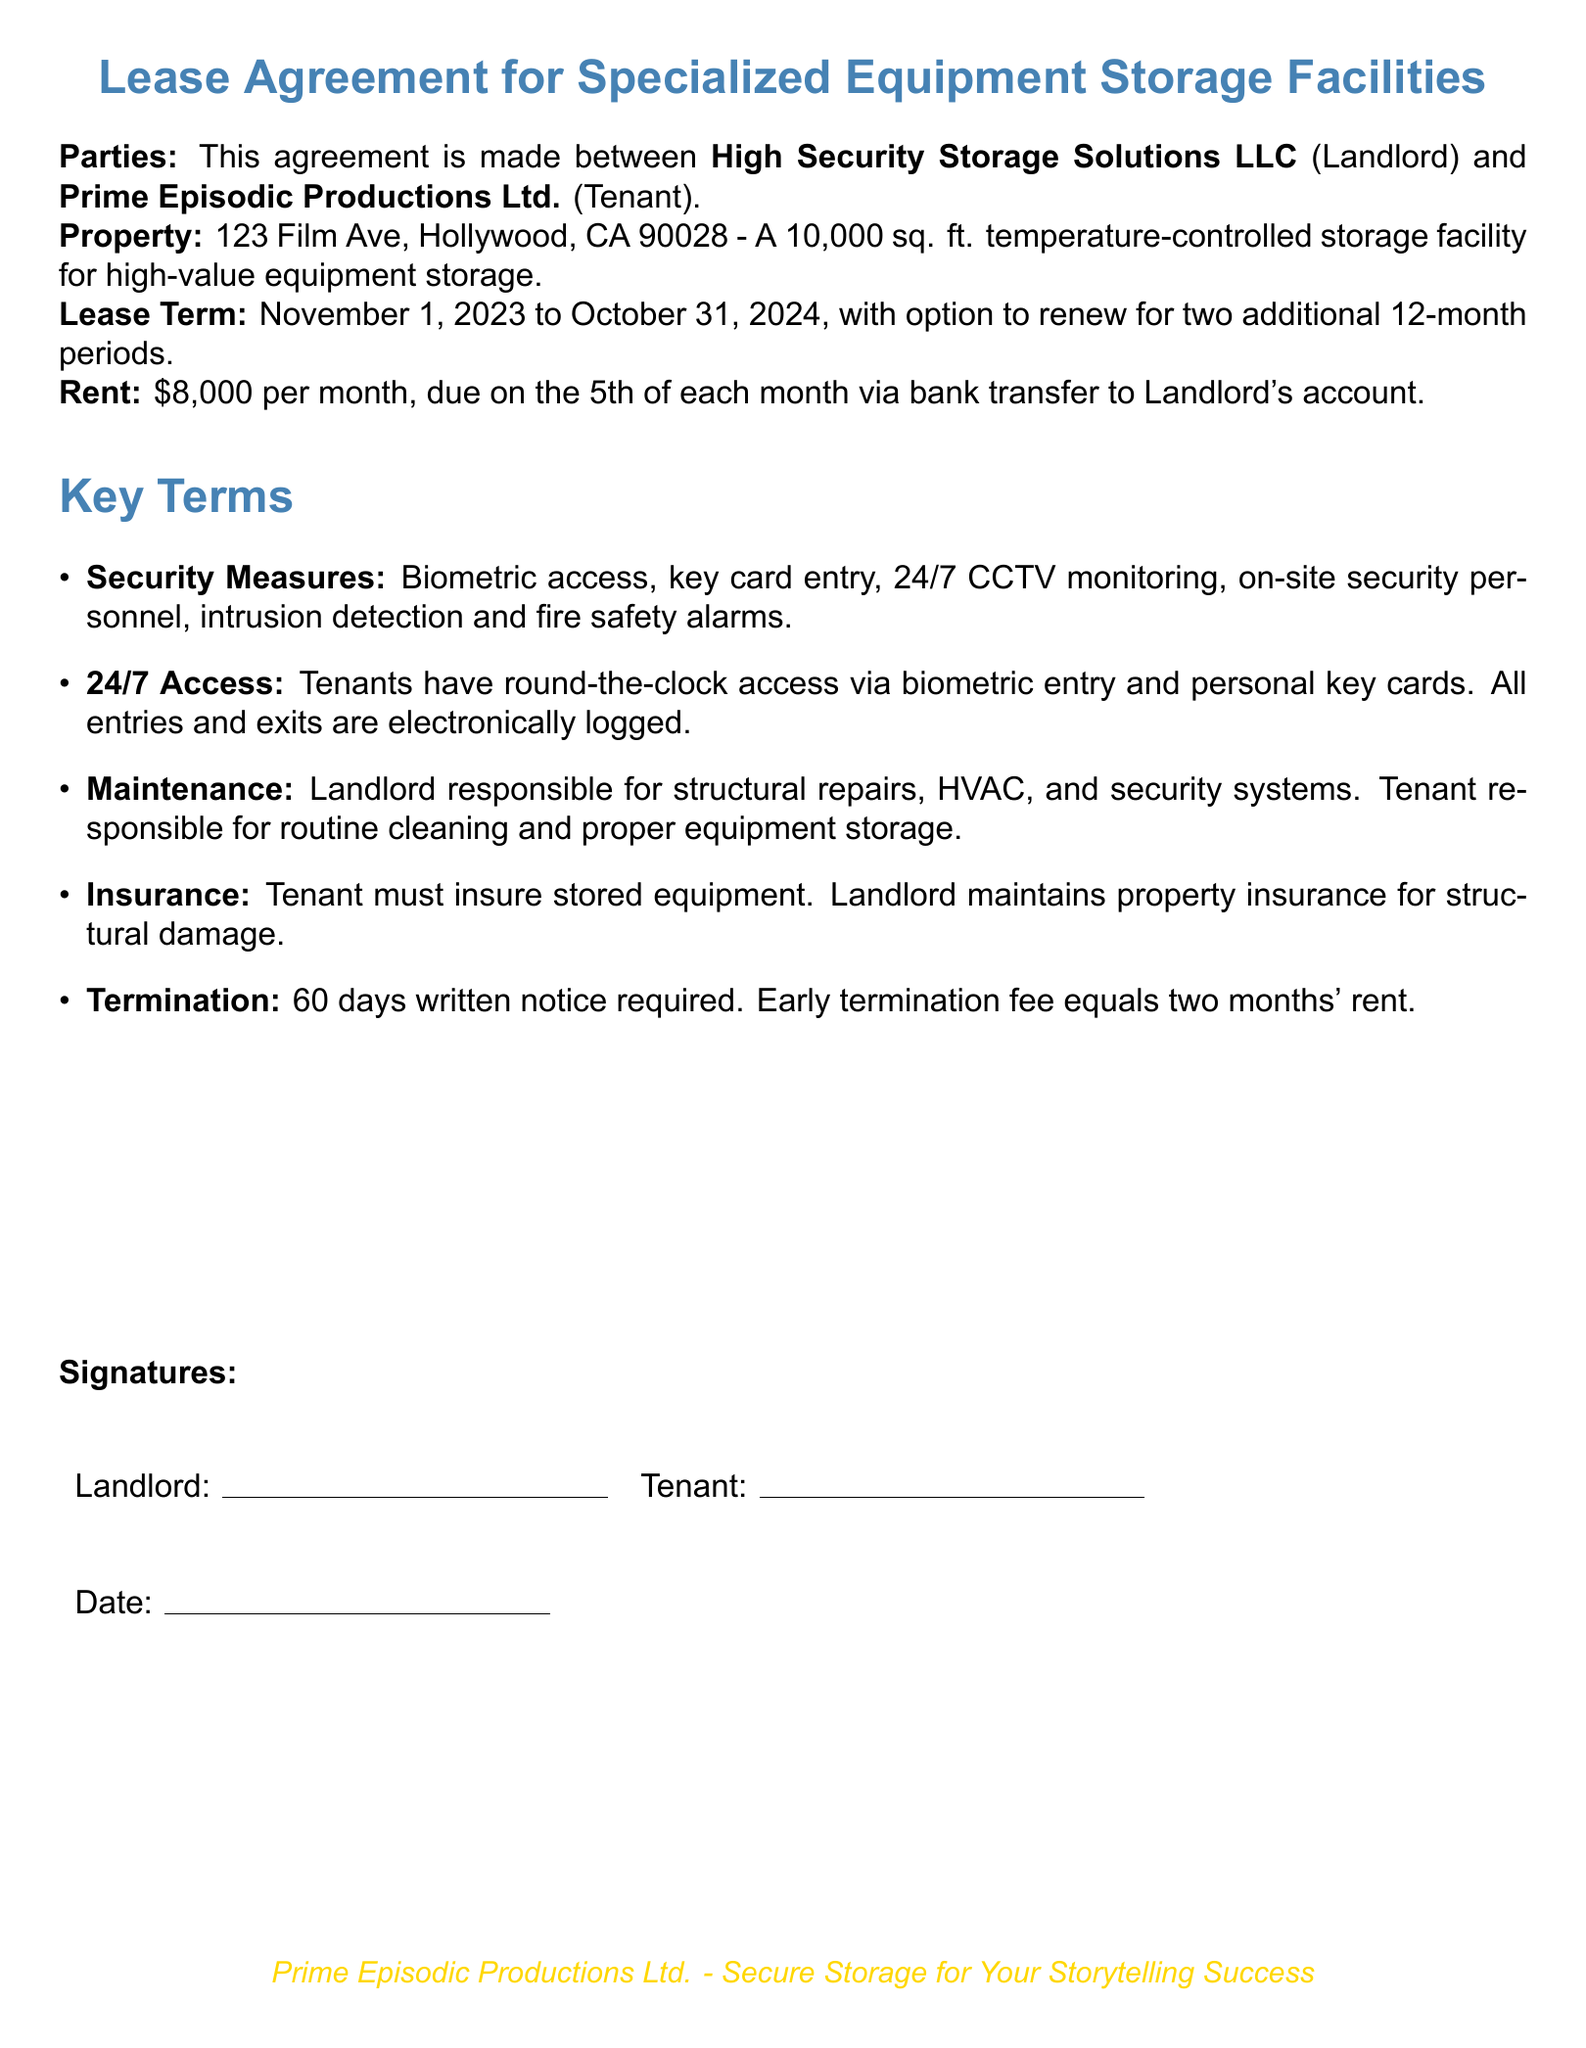What is the total square footage of the storage facility? The total square footage is stated in the document for the specialized equipment storage facility.
Answer: 10,000 sq. ft What is the monthly rent for the storage facility? The document specifies the rent amount that the Tenant is required to pay each month.
Answer: $8,000 Who are the parties involved in the lease agreement? The document names the two parties and their roles in the agreement.
Answer: High Security Storage Solutions LLC and Prime Episodic Productions Ltd What date does the lease term start? The document specifies the starting date for the lease term.
Answer: November 1, 2023 What security measures are included in the lease agreement? The document lists specific security measures that the Landlord provides for the facility.
Answer: Biometric access, key card entry, 24/7 CCTV monitoring, on-site security personnel, intrusion detection and fire safety alarms What is the notice period required for lease termination? The document stipulates the duration of the written notice needed for terminating the lease.
Answer: 60 days What does the Tenant need to insure? The document indicates what the Tenant is responsible for insuring during the lease term.
Answer: Stored equipment How often can the lease be renewed? The document states the number of additional periods for which the lease can be renewed after the initial term.
Answer: Two additional 12-month periods 